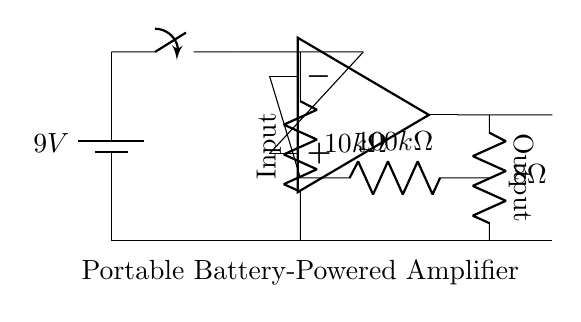What is the input resistance of this amplifier? The input resistance is 10k ohms, shown in the circuit diagram next to the resistor connected to the input jack.
Answer: 10k ohms What is the output load resistance? The output load resistance is 8 ohms, depicted next to the resistor connected at the output of the operational amplifier.
Answer: 8 ohms How many volts does the battery provide? The battery provides 9 volts, which is indicated on the battery symbol in the circuit diagram.
Answer: 9 volts What type of switch is used in this amplifier? The switch is a single-pole switch, which allows the circuit to be opened or closed. This can be derived from the switch symbol in the diagram.
Answer: Single-pole switch What is the role of the operational amplifier in this circuit? The operational amplifier amplifies the input signal applied at its input terminals, which enables field reporting equipment to work effectively by increasing the signal strength.
Answer: Signal amplification How does the resistor connected to the inverting input affect the gain? The resistor connected to the inverting input (100k ohms) determines the gain of the amplifier in conjunction with the feedback resistor. The gain can be calculated by the ratio of these resistances. A higher resistance at the input reduces the amount of feedback, increasing gain.
Answer: It affects gain What is the purpose of the on/off switch? The on/off switch controls the power supply from the battery to the entire circuit, allowing the user to turn the amplifier on or off as needed for energy conservation or to prepare for use.
Answer: Power control 